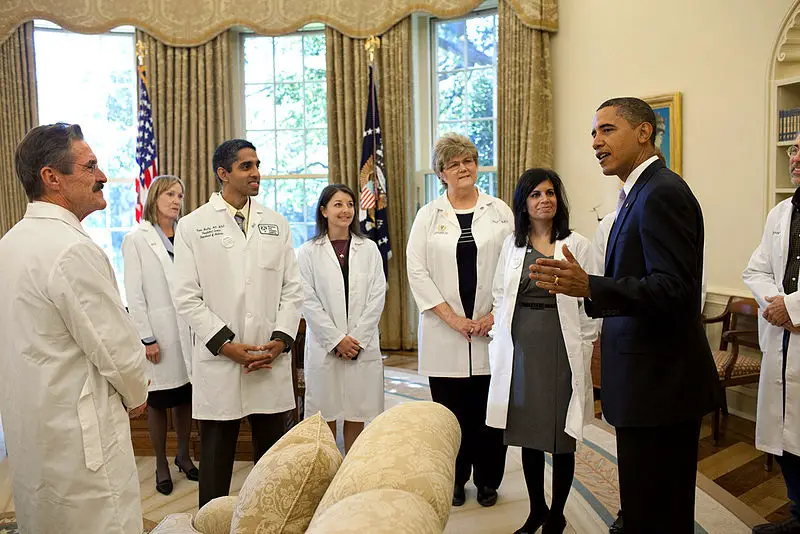Write a short fictional narrative inspired by this image. In the midst of a public health crisis, President Marcus stood in the Oval Office, surrounded by the nation's top medical experts. The gilded curtains framed the scene, sunlight streaming through the tall windows as Dr. Harris explained the potential impact of their latest vaccine development. The stakes were high. The team in white coats represented not just hope, but the collective resolve of a nation determined to overcome adversity. Together, they planned the campaign that would ensure every citizen had access to life-saving treatment, marking a pivotal moment in history. Expand this narrative into a longer story. President Marcus paced the polished floor of the Oval Office, his mind racing with the gravity of the situation. The country was in the throes of a public health emergency that had shown no signs of abating. Before him stood the best and brightest medical minds, their white coats symbolizing their dedication and skill. Dr. Harris, head of the national virology institute, broke the tense silence with an update. "Mr. President, we've made significant progress. Our latest trials show the vaccine is 95% effective in combating the virus."

The room buzzed with a mix of relief and cautious optimism. Dr. Keller, an epidemiologist, pointed to maps detailing the spread of the infection. "We need a coordinated effort to distribute the vaccine, prioritizing the hardest-hit regions first." Logistics officers discussed airlifts, while public relations experts strategized on effective communication to ensure public compliance.

President Marcus knew this was just the beginning. The path ahead would be fraught with challenges, but the resolve in the room was palpable. They worked late into the night, drafting plans, troubleshooting potential setbacks, and refining strategies. As dawn approached, the President stood by the window, gazing at the first light of a new day. Hope, bolstered by science and collaboration, filled the room. The battle was far from over, but together, they had taken the first significant step in turning the tide. 